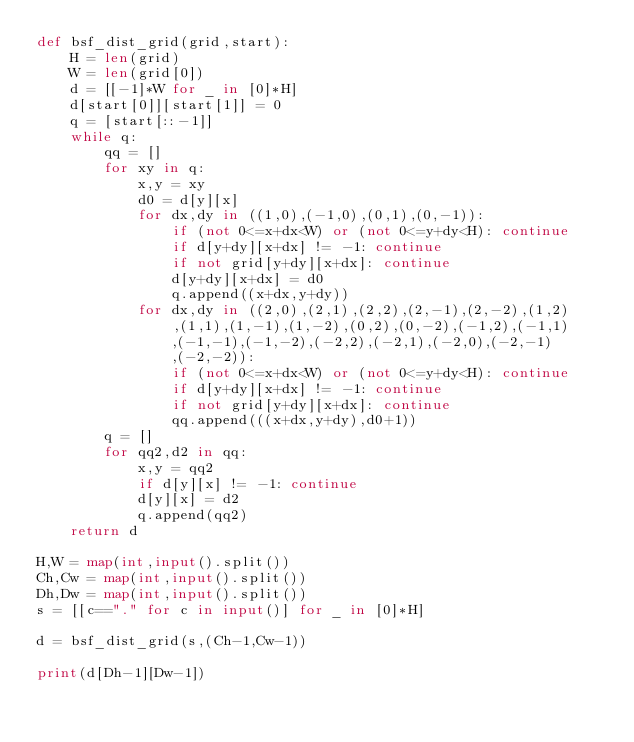Convert code to text. <code><loc_0><loc_0><loc_500><loc_500><_Python_>def bsf_dist_grid(grid,start):
    H = len(grid)
    W = len(grid[0])
    d = [[-1]*W for _ in [0]*H]
    d[start[0]][start[1]] = 0
    q = [start[::-1]]
    while q:
        qq = []
        for xy in q:
            x,y = xy
            d0 = d[y][x]
            for dx,dy in ((1,0),(-1,0),(0,1),(0,-1)):
                if (not 0<=x+dx<W) or (not 0<=y+dy<H): continue
                if d[y+dy][x+dx] != -1: continue
                if not grid[y+dy][x+dx]: continue
                d[y+dy][x+dx] = d0
                q.append((x+dx,y+dy))
            for dx,dy in ((2,0),(2,1),(2,2),(2,-1),(2,-2),(1,2),(1,1),(1,-1),(1,-2),(0,2),(0,-2),(-1,2),(-1,1),(-1,-1),(-1,-2),(-2,2),(-2,1),(-2,0),(-2,-1),(-2,-2)):
                if (not 0<=x+dx<W) or (not 0<=y+dy<H): continue
                if d[y+dy][x+dx] != -1: continue
                if not grid[y+dy][x+dx]: continue
                qq.append(((x+dx,y+dy),d0+1))
        q = []
        for qq2,d2 in qq:
            x,y = qq2
            if d[y][x] != -1: continue
            d[y][x] = d2
            q.append(qq2)
    return d

H,W = map(int,input().split())
Ch,Cw = map(int,input().split())
Dh,Dw = map(int,input().split())
s = [[c=="." for c in input()] for _ in [0]*H]

d = bsf_dist_grid(s,(Ch-1,Cw-1))

print(d[Dh-1][Dw-1])</code> 